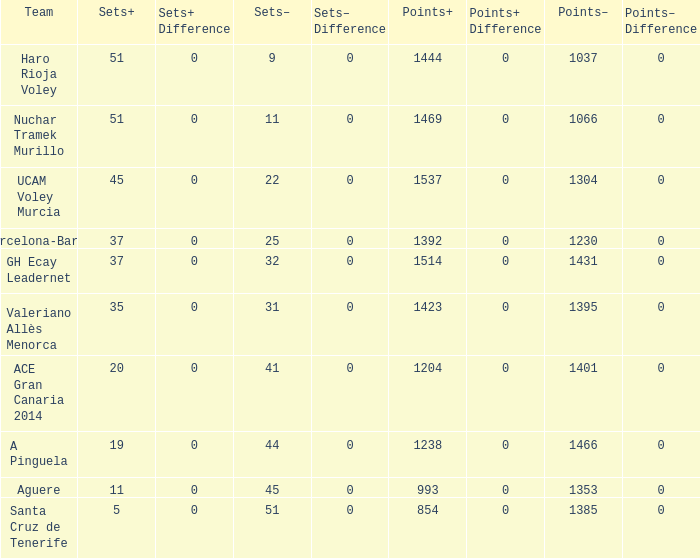What is the total number of Points- when the Sets- is larger than 51? 0.0. 